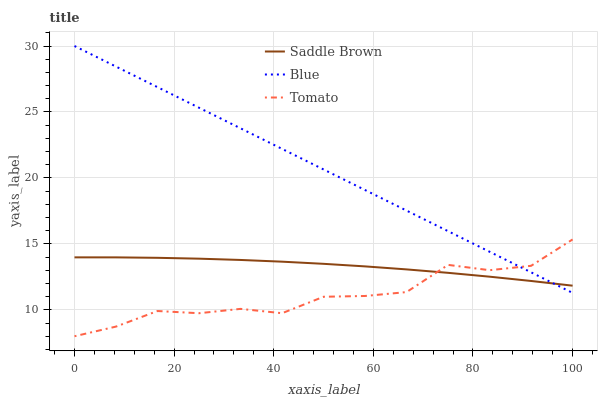Does Tomato have the minimum area under the curve?
Answer yes or no. Yes. Does Blue have the maximum area under the curve?
Answer yes or no. Yes. Does Saddle Brown have the minimum area under the curve?
Answer yes or no. No. Does Saddle Brown have the maximum area under the curve?
Answer yes or no. No. Is Blue the smoothest?
Answer yes or no. Yes. Is Tomato the roughest?
Answer yes or no. Yes. Is Saddle Brown the smoothest?
Answer yes or no. No. Is Saddle Brown the roughest?
Answer yes or no. No. Does Tomato have the lowest value?
Answer yes or no. Yes. Does Saddle Brown have the lowest value?
Answer yes or no. No. Does Blue have the highest value?
Answer yes or no. Yes. Does Tomato have the highest value?
Answer yes or no. No. Does Blue intersect Tomato?
Answer yes or no. Yes. Is Blue less than Tomato?
Answer yes or no. No. Is Blue greater than Tomato?
Answer yes or no. No. 